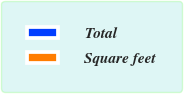Convert chart to OTSL. <chart><loc_0><loc_0><loc_500><loc_500><pie_chart><fcel>Total<fcel>Square feet<nl><fcel>0.0%<fcel>100.0%<nl></chart> 